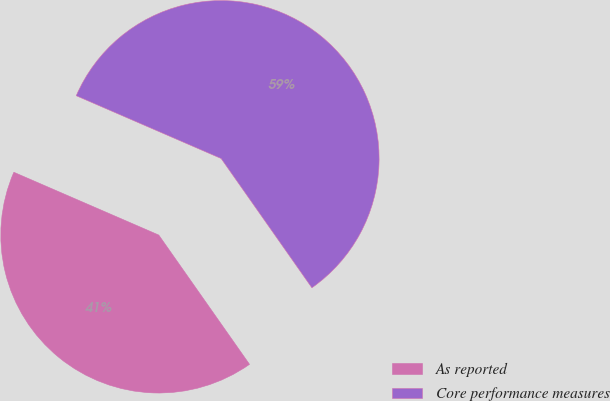<chart> <loc_0><loc_0><loc_500><loc_500><pie_chart><fcel>As reported<fcel>Core performance measures<nl><fcel>41.25%<fcel>58.75%<nl></chart> 